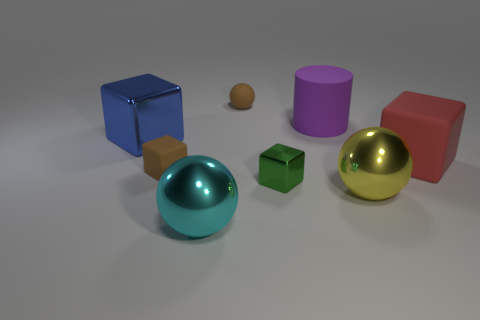Add 1 tiny brown rubber spheres. How many objects exist? 9 Subtract all yellow balls. How many balls are left? 2 Subtract all brown spheres. How many spheres are left? 2 Subtract all cylinders. How many objects are left? 7 Subtract 1 cubes. How many cubes are left? 3 Subtract all purple spheres. Subtract all gray blocks. How many spheres are left? 3 Subtract all green spheres. How many yellow blocks are left? 0 Subtract all small gray cylinders. Subtract all large red matte blocks. How many objects are left? 7 Add 3 rubber cylinders. How many rubber cylinders are left? 4 Add 3 tiny green things. How many tiny green things exist? 4 